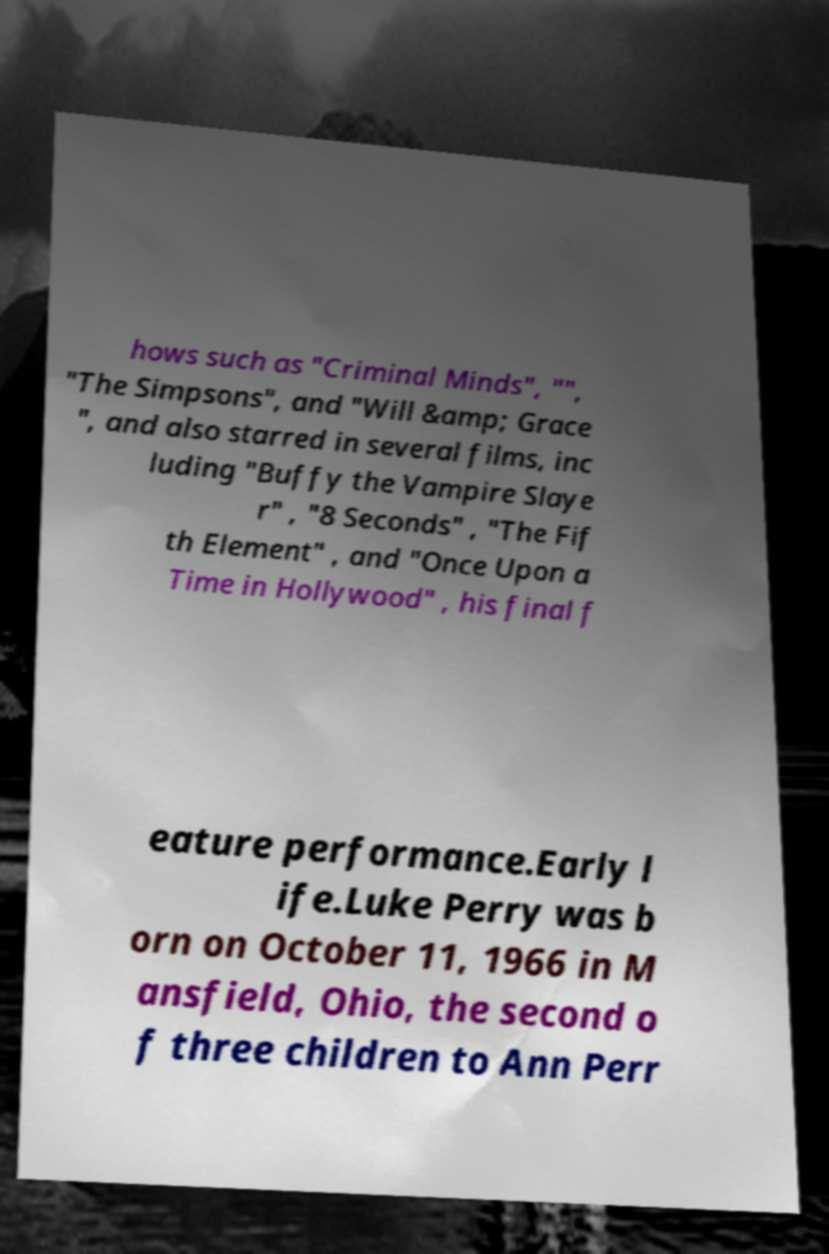For documentation purposes, I need the text within this image transcribed. Could you provide that? hows such as "Criminal Minds", "", "The Simpsons", and "Will &amp; Grace ", and also starred in several films, inc luding "Buffy the Vampire Slaye r" , "8 Seconds" , "The Fif th Element" , and "Once Upon a Time in Hollywood" , his final f eature performance.Early l ife.Luke Perry was b orn on October 11, 1966 in M ansfield, Ohio, the second o f three children to Ann Perr 